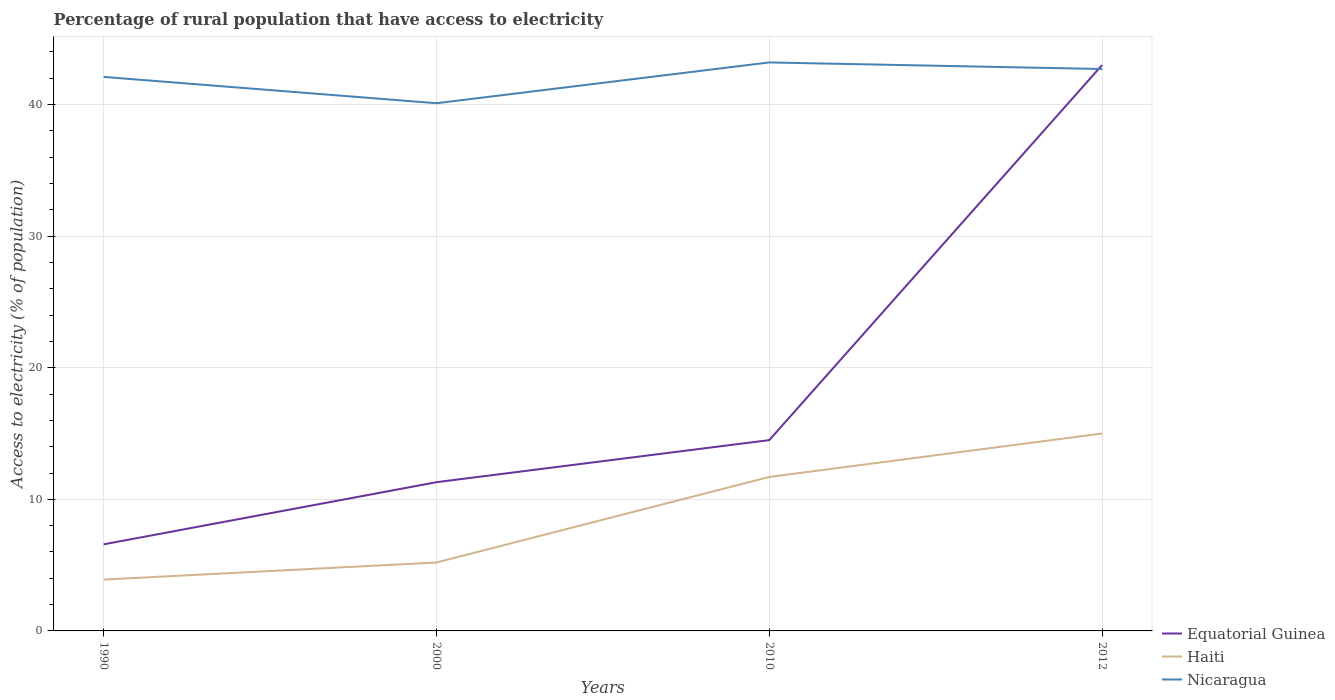Across all years, what is the maximum percentage of rural population that have access to electricity in Haiti?
Your response must be concise. 3.9. What is the total percentage of rural population that have access to electricity in Nicaragua in the graph?
Your answer should be very brief. -2.6. What is the difference between the highest and the second highest percentage of rural population that have access to electricity in Equatorial Guinea?
Your answer should be compact. 36.42. Does the graph contain grids?
Your answer should be very brief. Yes. Where does the legend appear in the graph?
Your response must be concise. Bottom right. How are the legend labels stacked?
Your answer should be very brief. Vertical. What is the title of the graph?
Ensure brevity in your answer.  Percentage of rural population that have access to electricity. What is the label or title of the X-axis?
Provide a short and direct response. Years. What is the label or title of the Y-axis?
Offer a very short reply. Access to electricity (% of population). What is the Access to electricity (% of population) of Equatorial Guinea in 1990?
Give a very brief answer. 6.58. What is the Access to electricity (% of population) of Nicaragua in 1990?
Your answer should be compact. 42.1. What is the Access to electricity (% of population) of Equatorial Guinea in 2000?
Provide a short and direct response. 11.3. What is the Access to electricity (% of population) in Nicaragua in 2000?
Ensure brevity in your answer.  40.1. What is the Access to electricity (% of population) of Nicaragua in 2010?
Provide a short and direct response. 43.2. What is the Access to electricity (% of population) in Haiti in 2012?
Provide a short and direct response. 15. What is the Access to electricity (% of population) of Nicaragua in 2012?
Keep it short and to the point. 42.7. Across all years, what is the maximum Access to electricity (% of population) in Equatorial Guinea?
Your answer should be very brief. 43. Across all years, what is the maximum Access to electricity (% of population) of Nicaragua?
Provide a succinct answer. 43.2. Across all years, what is the minimum Access to electricity (% of population) of Equatorial Guinea?
Your answer should be compact. 6.58. Across all years, what is the minimum Access to electricity (% of population) in Nicaragua?
Make the answer very short. 40.1. What is the total Access to electricity (% of population) of Equatorial Guinea in the graph?
Provide a short and direct response. 75.38. What is the total Access to electricity (% of population) of Haiti in the graph?
Provide a succinct answer. 35.8. What is the total Access to electricity (% of population) of Nicaragua in the graph?
Make the answer very short. 168.1. What is the difference between the Access to electricity (% of population) of Equatorial Guinea in 1990 and that in 2000?
Offer a terse response. -4.72. What is the difference between the Access to electricity (% of population) of Haiti in 1990 and that in 2000?
Your response must be concise. -1.3. What is the difference between the Access to electricity (% of population) of Nicaragua in 1990 and that in 2000?
Your answer should be compact. 2. What is the difference between the Access to electricity (% of population) in Equatorial Guinea in 1990 and that in 2010?
Keep it short and to the point. -7.92. What is the difference between the Access to electricity (% of population) in Nicaragua in 1990 and that in 2010?
Offer a very short reply. -1.1. What is the difference between the Access to electricity (% of population) of Equatorial Guinea in 1990 and that in 2012?
Provide a succinct answer. -36.42. What is the difference between the Access to electricity (% of population) of Nicaragua in 1990 and that in 2012?
Make the answer very short. -0.6. What is the difference between the Access to electricity (% of population) in Equatorial Guinea in 2000 and that in 2010?
Offer a very short reply. -3.2. What is the difference between the Access to electricity (% of population) in Nicaragua in 2000 and that in 2010?
Keep it short and to the point. -3.1. What is the difference between the Access to electricity (% of population) of Equatorial Guinea in 2000 and that in 2012?
Offer a terse response. -31.7. What is the difference between the Access to electricity (% of population) in Equatorial Guinea in 2010 and that in 2012?
Offer a very short reply. -28.5. What is the difference between the Access to electricity (% of population) of Haiti in 2010 and that in 2012?
Give a very brief answer. -3.3. What is the difference between the Access to electricity (% of population) in Nicaragua in 2010 and that in 2012?
Your answer should be very brief. 0.5. What is the difference between the Access to electricity (% of population) of Equatorial Guinea in 1990 and the Access to electricity (% of population) of Haiti in 2000?
Offer a terse response. 1.38. What is the difference between the Access to electricity (% of population) in Equatorial Guinea in 1990 and the Access to electricity (% of population) in Nicaragua in 2000?
Your response must be concise. -33.52. What is the difference between the Access to electricity (% of population) in Haiti in 1990 and the Access to electricity (% of population) in Nicaragua in 2000?
Ensure brevity in your answer.  -36.2. What is the difference between the Access to electricity (% of population) of Equatorial Guinea in 1990 and the Access to electricity (% of population) of Haiti in 2010?
Provide a short and direct response. -5.12. What is the difference between the Access to electricity (% of population) of Equatorial Guinea in 1990 and the Access to electricity (% of population) of Nicaragua in 2010?
Provide a short and direct response. -36.62. What is the difference between the Access to electricity (% of population) of Haiti in 1990 and the Access to electricity (% of population) of Nicaragua in 2010?
Keep it short and to the point. -39.3. What is the difference between the Access to electricity (% of population) of Equatorial Guinea in 1990 and the Access to electricity (% of population) of Haiti in 2012?
Keep it short and to the point. -8.42. What is the difference between the Access to electricity (% of population) in Equatorial Guinea in 1990 and the Access to electricity (% of population) in Nicaragua in 2012?
Keep it short and to the point. -36.12. What is the difference between the Access to electricity (% of population) in Haiti in 1990 and the Access to electricity (% of population) in Nicaragua in 2012?
Your answer should be very brief. -38.8. What is the difference between the Access to electricity (% of population) of Equatorial Guinea in 2000 and the Access to electricity (% of population) of Haiti in 2010?
Your answer should be very brief. -0.4. What is the difference between the Access to electricity (% of population) of Equatorial Guinea in 2000 and the Access to electricity (% of population) of Nicaragua in 2010?
Your answer should be compact. -31.9. What is the difference between the Access to electricity (% of population) in Haiti in 2000 and the Access to electricity (% of population) in Nicaragua in 2010?
Provide a short and direct response. -38. What is the difference between the Access to electricity (% of population) in Equatorial Guinea in 2000 and the Access to electricity (% of population) in Haiti in 2012?
Provide a succinct answer. -3.7. What is the difference between the Access to electricity (% of population) in Equatorial Guinea in 2000 and the Access to electricity (% of population) in Nicaragua in 2012?
Offer a very short reply. -31.4. What is the difference between the Access to electricity (% of population) of Haiti in 2000 and the Access to electricity (% of population) of Nicaragua in 2012?
Give a very brief answer. -37.5. What is the difference between the Access to electricity (% of population) of Equatorial Guinea in 2010 and the Access to electricity (% of population) of Haiti in 2012?
Make the answer very short. -0.5. What is the difference between the Access to electricity (% of population) of Equatorial Guinea in 2010 and the Access to electricity (% of population) of Nicaragua in 2012?
Your answer should be very brief. -28.2. What is the difference between the Access to electricity (% of population) of Haiti in 2010 and the Access to electricity (% of population) of Nicaragua in 2012?
Your response must be concise. -31. What is the average Access to electricity (% of population) of Equatorial Guinea per year?
Your answer should be very brief. 18.85. What is the average Access to electricity (% of population) in Haiti per year?
Offer a very short reply. 8.95. What is the average Access to electricity (% of population) in Nicaragua per year?
Your response must be concise. 42.02. In the year 1990, what is the difference between the Access to electricity (% of population) of Equatorial Guinea and Access to electricity (% of population) of Haiti?
Give a very brief answer. 2.68. In the year 1990, what is the difference between the Access to electricity (% of population) of Equatorial Guinea and Access to electricity (% of population) of Nicaragua?
Your answer should be compact. -35.52. In the year 1990, what is the difference between the Access to electricity (% of population) in Haiti and Access to electricity (% of population) in Nicaragua?
Offer a terse response. -38.2. In the year 2000, what is the difference between the Access to electricity (% of population) of Equatorial Guinea and Access to electricity (% of population) of Haiti?
Offer a very short reply. 6.1. In the year 2000, what is the difference between the Access to electricity (% of population) in Equatorial Guinea and Access to electricity (% of population) in Nicaragua?
Ensure brevity in your answer.  -28.8. In the year 2000, what is the difference between the Access to electricity (% of population) of Haiti and Access to electricity (% of population) of Nicaragua?
Your answer should be very brief. -34.9. In the year 2010, what is the difference between the Access to electricity (% of population) in Equatorial Guinea and Access to electricity (% of population) in Haiti?
Your answer should be very brief. 2.8. In the year 2010, what is the difference between the Access to electricity (% of population) of Equatorial Guinea and Access to electricity (% of population) of Nicaragua?
Your answer should be very brief. -28.7. In the year 2010, what is the difference between the Access to electricity (% of population) in Haiti and Access to electricity (% of population) in Nicaragua?
Offer a terse response. -31.5. In the year 2012, what is the difference between the Access to electricity (% of population) of Equatorial Guinea and Access to electricity (% of population) of Haiti?
Ensure brevity in your answer.  28. In the year 2012, what is the difference between the Access to electricity (% of population) in Haiti and Access to electricity (% of population) in Nicaragua?
Your answer should be compact. -27.7. What is the ratio of the Access to electricity (% of population) in Equatorial Guinea in 1990 to that in 2000?
Offer a very short reply. 0.58. What is the ratio of the Access to electricity (% of population) of Haiti in 1990 to that in 2000?
Provide a short and direct response. 0.75. What is the ratio of the Access to electricity (% of population) in Nicaragua in 1990 to that in 2000?
Your answer should be very brief. 1.05. What is the ratio of the Access to electricity (% of population) in Equatorial Guinea in 1990 to that in 2010?
Offer a very short reply. 0.45. What is the ratio of the Access to electricity (% of population) of Haiti in 1990 to that in 2010?
Provide a short and direct response. 0.33. What is the ratio of the Access to electricity (% of population) of Nicaragua in 1990 to that in 2010?
Offer a very short reply. 0.97. What is the ratio of the Access to electricity (% of population) in Equatorial Guinea in 1990 to that in 2012?
Keep it short and to the point. 0.15. What is the ratio of the Access to electricity (% of population) of Haiti in 1990 to that in 2012?
Make the answer very short. 0.26. What is the ratio of the Access to electricity (% of population) in Nicaragua in 1990 to that in 2012?
Your response must be concise. 0.99. What is the ratio of the Access to electricity (% of population) in Equatorial Guinea in 2000 to that in 2010?
Your response must be concise. 0.78. What is the ratio of the Access to electricity (% of population) of Haiti in 2000 to that in 2010?
Provide a succinct answer. 0.44. What is the ratio of the Access to electricity (% of population) of Nicaragua in 2000 to that in 2010?
Make the answer very short. 0.93. What is the ratio of the Access to electricity (% of population) in Equatorial Guinea in 2000 to that in 2012?
Provide a short and direct response. 0.26. What is the ratio of the Access to electricity (% of population) in Haiti in 2000 to that in 2012?
Provide a short and direct response. 0.35. What is the ratio of the Access to electricity (% of population) of Nicaragua in 2000 to that in 2012?
Provide a succinct answer. 0.94. What is the ratio of the Access to electricity (% of population) in Equatorial Guinea in 2010 to that in 2012?
Your answer should be very brief. 0.34. What is the ratio of the Access to electricity (% of population) in Haiti in 2010 to that in 2012?
Your answer should be compact. 0.78. What is the ratio of the Access to electricity (% of population) of Nicaragua in 2010 to that in 2012?
Keep it short and to the point. 1.01. What is the difference between the highest and the second highest Access to electricity (% of population) of Equatorial Guinea?
Offer a terse response. 28.5. What is the difference between the highest and the second highest Access to electricity (% of population) in Nicaragua?
Your response must be concise. 0.5. What is the difference between the highest and the lowest Access to electricity (% of population) in Equatorial Guinea?
Make the answer very short. 36.42. What is the difference between the highest and the lowest Access to electricity (% of population) in Haiti?
Provide a succinct answer. 11.1. What is the difference between the highest and the lowest Access to electricity (% of population) of Nicaragua?
Offer a very short reply. 3.1. 